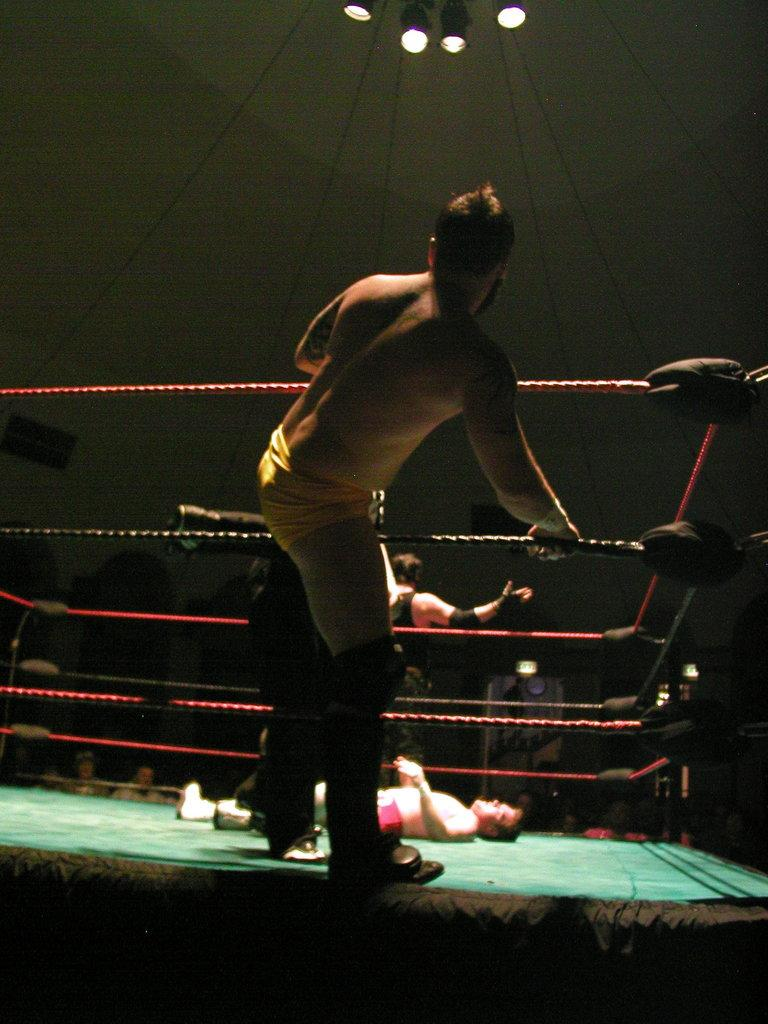How many people are in the image? There are people in the image, but the exact number is not specified. What is the position of one of the people in the image? One person is lying at the bottom of the image. What objects can be seen in the image besides people? There are ropes and lights visible in the image. Can you tell me how many potatoes are being held by the bear in the image? There is no bear or potatoes present in the image. 